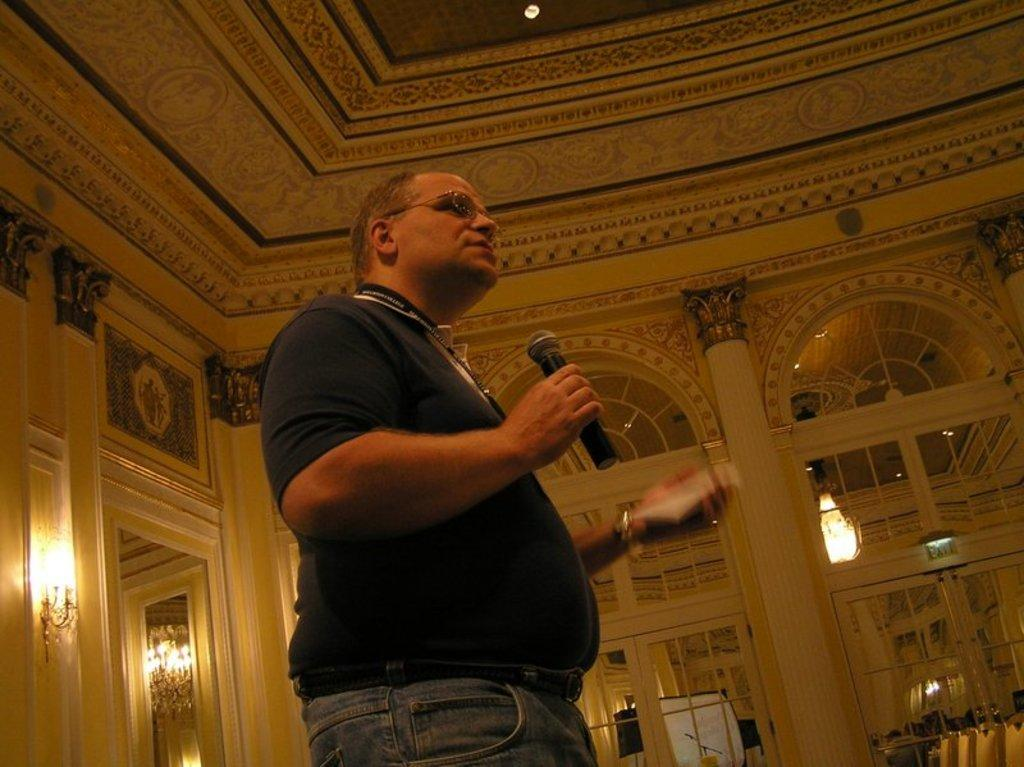Who is the main subject in the image? There is a man in the center of the image. What is the man holding in his hand? The man is holding a mic in his hand. What type of lighting is present in the image? There are lamps in the image. What architectural features can be seen in the image? There are arches in the image. What reflective objects are present in the image? There are mirrors in the image. What type of skirt is the representative wearing in the image? There is no representative or skirt present in the image. What type of alley can be seen in the image? There is no alley present in the image. 